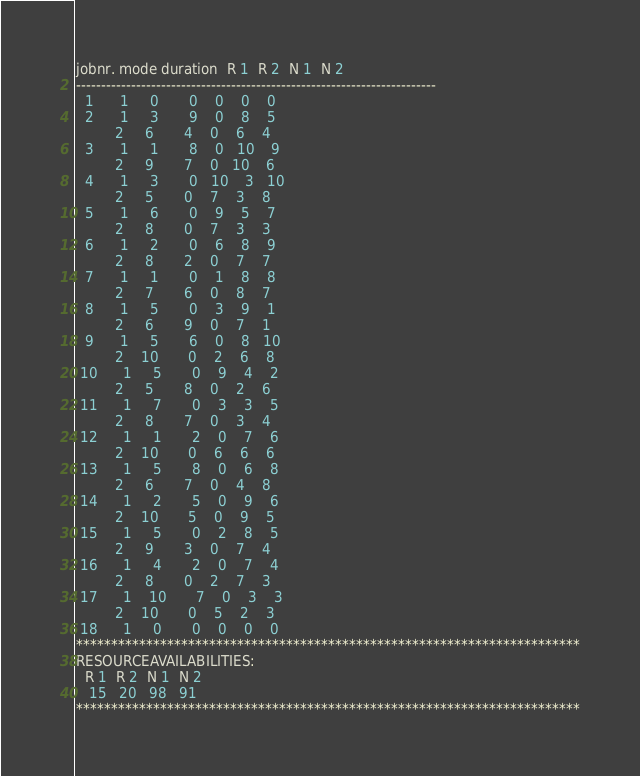Convert code to text. <code><loc_0><loc_0><loc_500><loc_500><_ObjectiveC_>jobnr. mode duration  R 1  R 2  N 1  N 2
------------------------------------------------------------------------
  1      1     0       0    0    0    0
  2      1     3       9    0    8    5
         2     6       4    0    6    4
  3      1     1       8    0   10    9
         2     9       7    0   10    6
  4      1     3       0   10    3   10
         2     5       0    7    3    8
  5      1     6       0    9    5    7
         2     8       0    7    3    3
  6      1     2       0    6    8    9
         2     8       2    0    7    7
  7      1     1       0    1    8    8
         2     7       6    0    8    7
  8      1     5       0    3    9    1
         2     6       9    0    7    1
  9      1     5       6    0    8   10
         2    10       0    2    6    8
 10      1     5       0    9    4    2
         2     5       8    0    2    6
 11      1     7       0    3    3    5
         2     8       7    0    3    4
 12      1     1       2    0    7    6
         2    10       0    6    6    6
 13      1     5       8    0    6    8
         2     6       7    0    4    8
 14      1     2       5    0    9    6
         2    10       5    0    9    5
 15      1     5       0    2    8    5
         2     9       3    0    7    4
 16      1     4       2    0    7    4
         2     8       0    2    7    3
 17      1    10       7    0    3    3
         2    10       0    5    2    3
 18      1     0       0    0    0    0
************************************************************************
RESOURCEAVAILABILITIES:
  R 1  R 2  N 1  N 2
   15   20   98   91
************************************************************************
</code> 